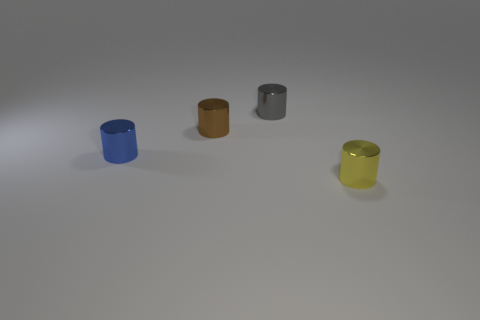Subtract all brown cylinders. Subtract all green balls. How many cylinders are left? 3 Add 4 large gray cylinders. How many objects exist? 8 Subtract all tiny yellow metallic objects. Subtract all brown things. How many objects are left? 2 Add 4 small yellow objects. How many small yellow objects are left? 5 Add 4 large red cylinders. How many large red cylinders exist? 4 Subtract 0 brown spheres. How many objects are left? 4 